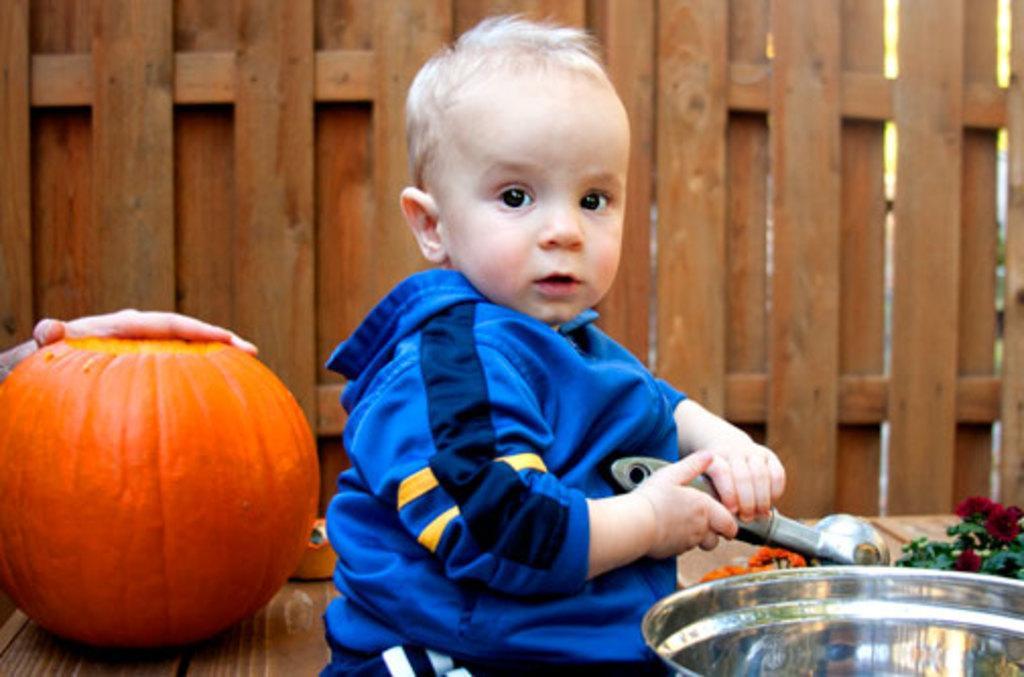Please provide a concise description of this image. This boy is holding an object. Background there is a wooden wall, pumpkin and person hand. Here we can see a container and plant. 